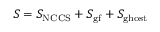<formula> <loc_0><loc_0><loc_500><loc_500>S = S _ { N C C S } + S _ { g f } + S _ { g h o s t }</formula> 